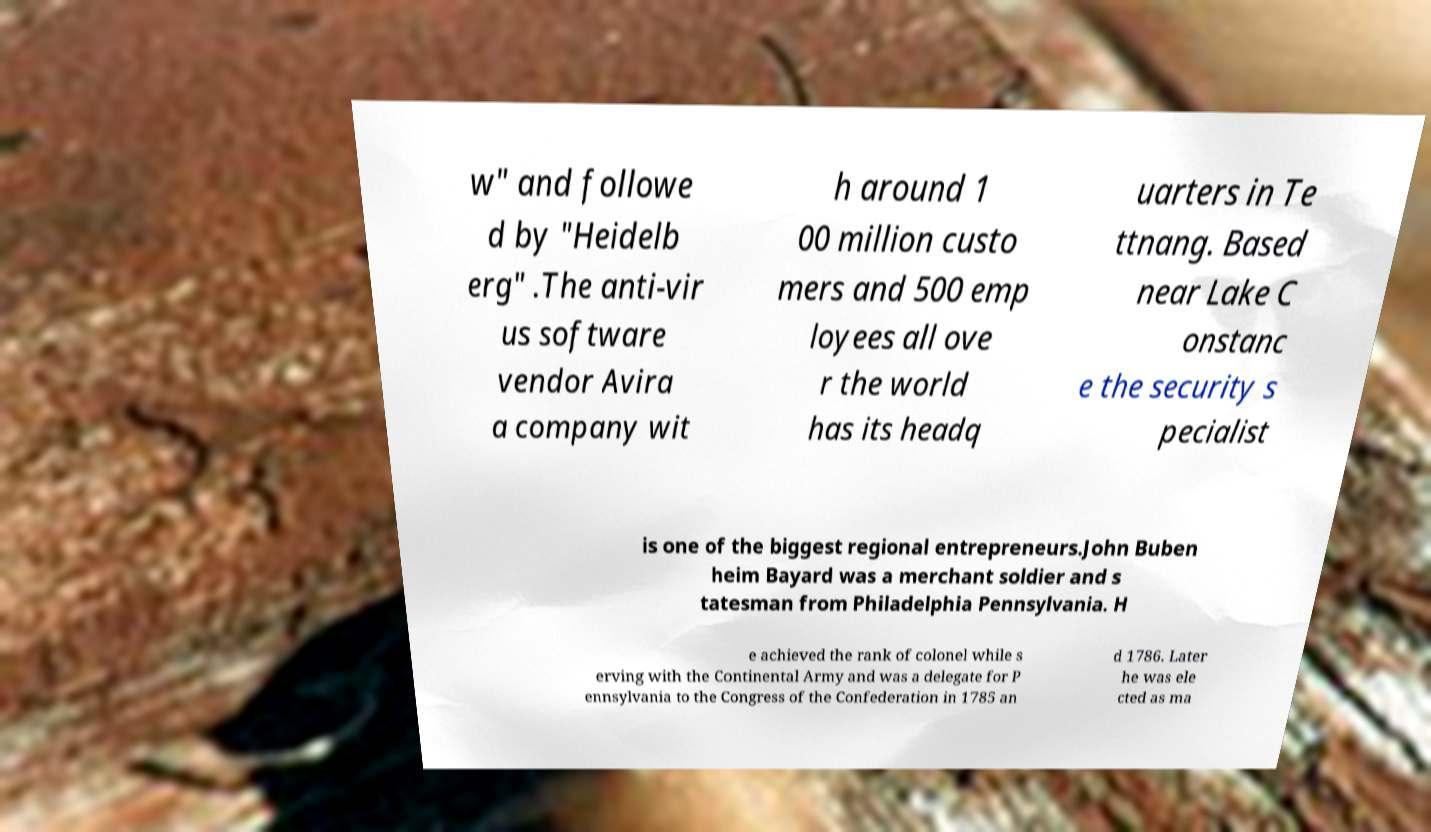What messages or text are displayed in this image? I need them in a readable, typed format. w" and followe d by "Heidelb erg" .The anti-vir us software vendor Avira a company wit h around 1 00 million custo mers and 500 emp loyees all ove r the world has its headq uarters in Te ttnang. Based near Lake C onstanc e the security s pecialist is one of the biggest regional entrepreneurs.John Buben heim Bayard was a merchant soldier and s tatesman from Philadelphia Pennsylvania. H e achieved the rank of colonel while s erving with the Continental Army and was a delegate for P ennsylvania to the Congress of the Confederation in 1785 an d 1786. Later he was ele cted as ma 